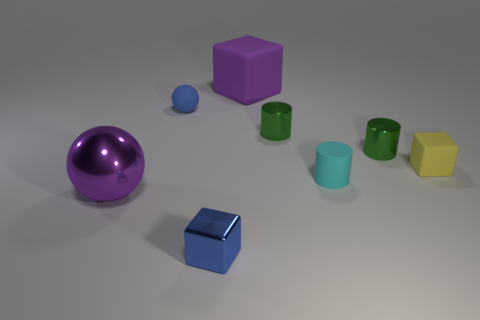Do the small green object that is on the left side of the tiny rubber cylinder and the small yellow object have the same material?
Provide a succinct answer. No. What is the size of the matte cube in front of the large purple matte cube?
Offer a very short reply. Small. There is a yellow matte object that is to the right of the large cube; is there a blue metallic thing that is in front of it?
Give a very brief answer. Yes. Do the big thing that is in front of the yellow matte block and the rubber cube on the left side of the cyan thing have the same color?
Provide a succinct answer. Yes. The large block has what color?
Make the answer very short. Purple. Is there anything else of the same color as the big metallic object?
Your answer should be compact. Yes. There is a rubber thing that is on the left side of the cyan object and to the right of the blue matte sphere; what color is it?
Ensure brevity in your answer.  Purple. There is a purple thing behind the blue matte sphere; is it the same size as the blue cube?
Keep it short and to the point. No. Are there more tiny things behind the rubber cylinder than big matte balls?
Your answer should be very brief. Yes. Do the large rubber thing and the yellow rubber object have the same shape?
Offer a terse response. Yes. 